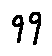<formula> <loc_0><loc_0><loc_500><loc_500>9 9</formula> 